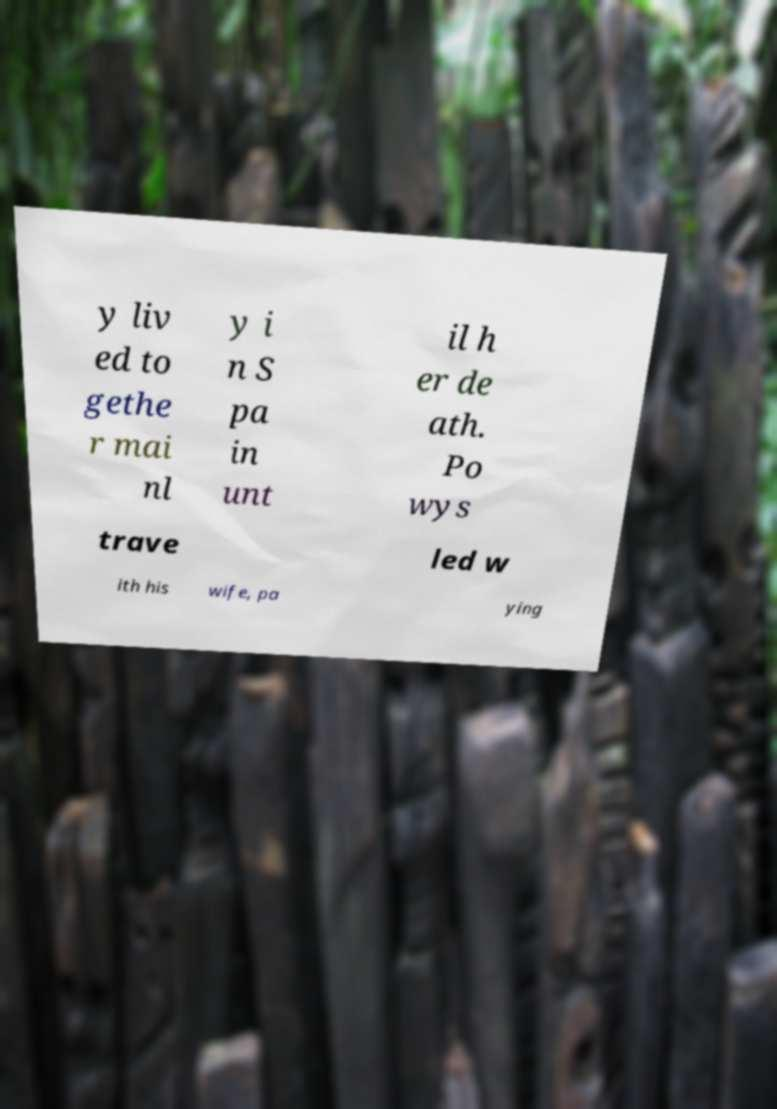Could you assist in decoding the text presented in this image and type it out clearly? y liv ed to gethe r mai nl y i n S pa in unt il h er de ath. Po wys trave led w ith his wife, pa ying 